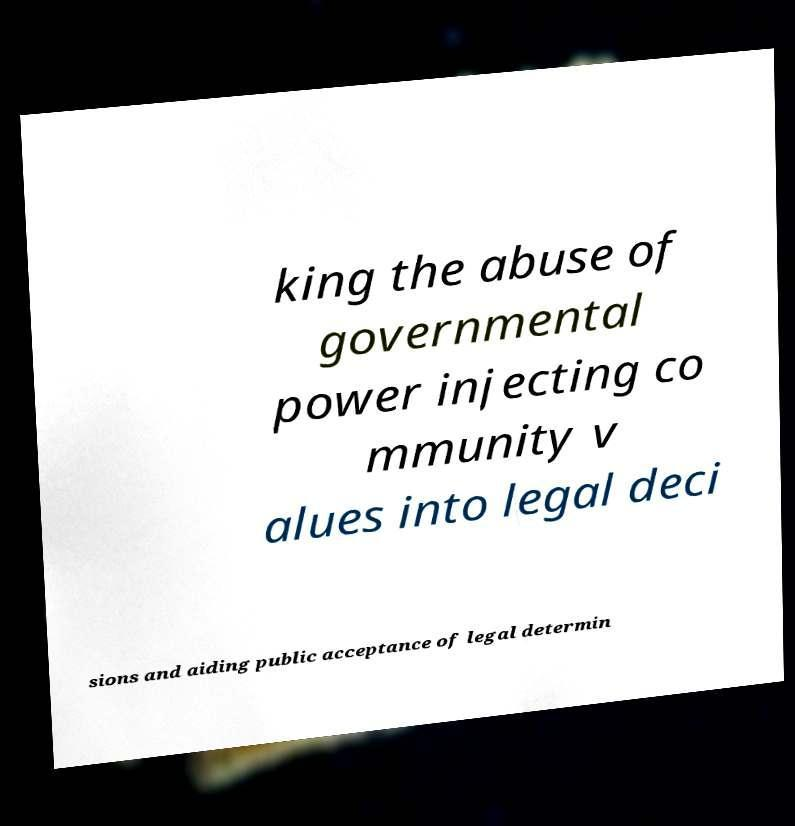I need the written content from this picture converted into text. Can you do that? king the abuse of governmental power injecting co mmunity v alues into legal deci sions and aiding public acceptance of legal determin 